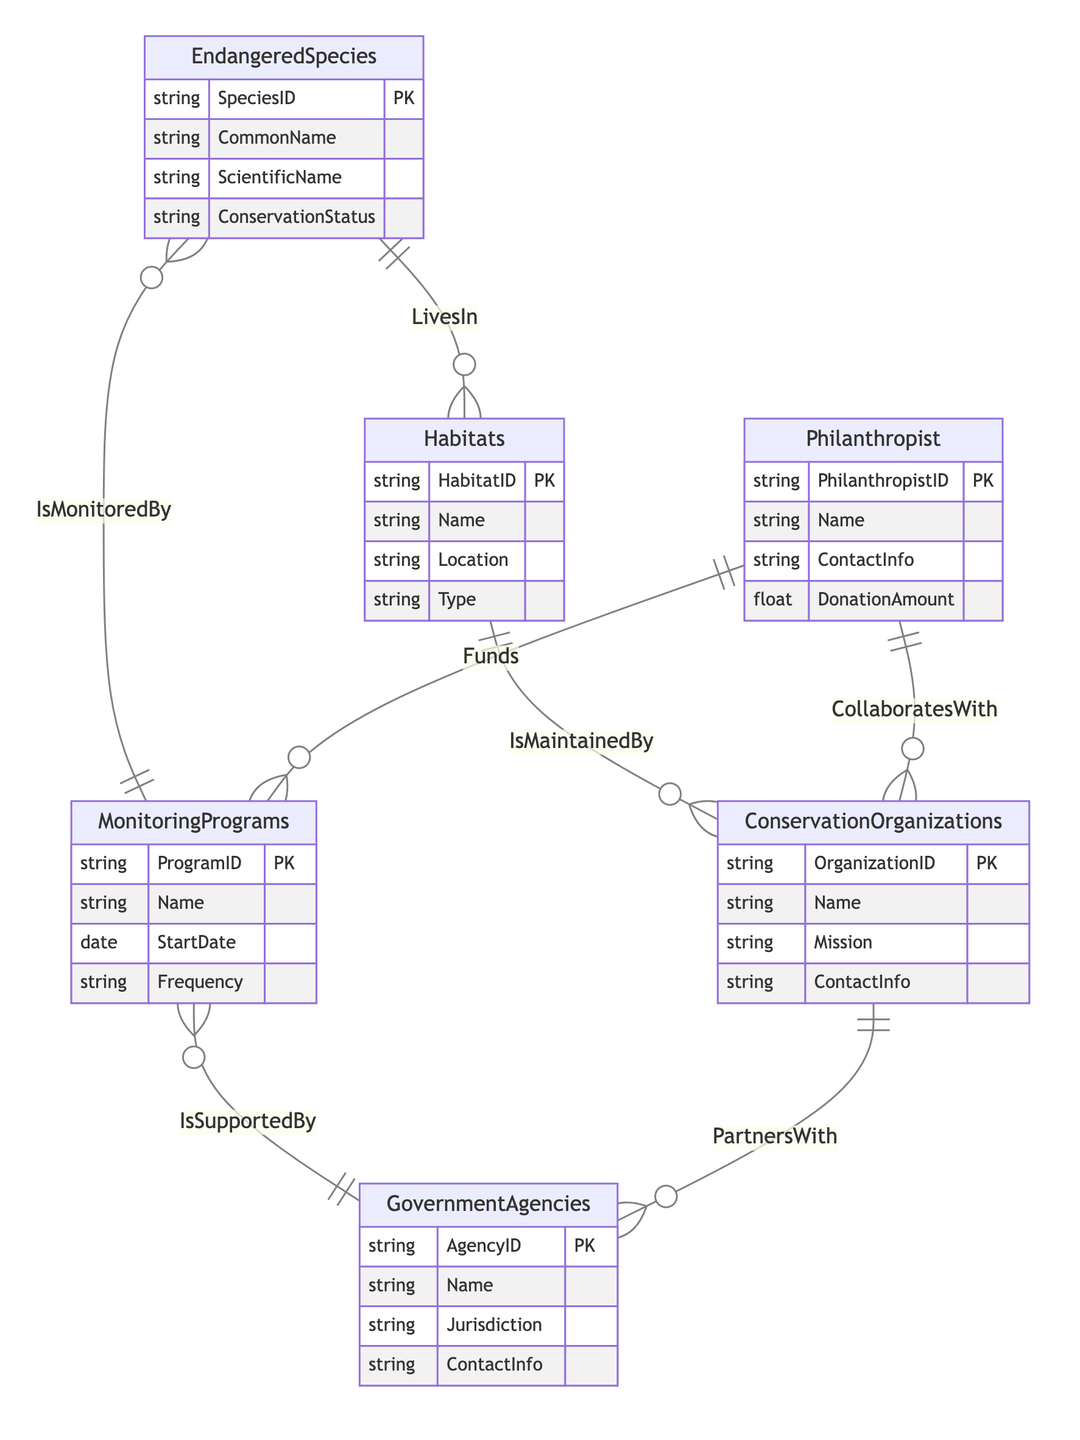What are the attributes of Endangered Species? The attributes of the Endangered Species entity in the diagram are SpeciesID, CommonName, ScientificName, and ConservationStatus.
Answer: SpeciesID, CommonName, ScientificName, ConservationStatus How many relationships are there for Conservation Organizations? The Conservation Organizations entity has three defined relationships: Maintains with Habitats, CollaboratesWith with Philanthropist, and PartnersWith with Government Agencies. Therefore, there are three relationships.
Answer: 3 What relationship exists between Government Agencies and Monitoring Programs? In the diagram, the relationship between Government Agencies and Monitoring Programs is defined as "IsSupportedBy." This indicates that Government Agencies provide support to these Monitoring Programs.
Answer: IsSupportedBy Which entity is funded by Philanthropist? According to the diagram, the Monitoring Programs are funded by the Philanthropist entity. This is shown through the relationship "Funds" connecting the two entities.
Answer: Monitoring Programs What does the Habitats entity maintain? The Habitats entity is maintained by Conservation Organizations, as indicated by the relationship labeled "IsMaintainedBy" in the diagram.
Answer: Conservation Organizations How many types of relationships connect Endangered Species with other entities? The Endangered Species entity connects with two entities through the relationships "LivesIn" with Habitats and "IsMonitoredBy" with Monitoring Programs. Thus, there are two types of relationships connecting Endangered Species.
Answer: 2 What kind of relationship do Conservation Organizations have with Government Agencies? The relationship that Conservation Organizations have with Government Agencies is labeled "PartnersWith." This signifies a partnership or collaborative connection between the two entities.
Answer: PartnersWith What is the donation amount attributed to Philanthropist? The Philanthropist entity has an attribute defined as DonationAmount. However, since no specific amount is provided in the diagram context, it is understood generally as a monetary value that is subject to input.
Answer: DonationAmount 